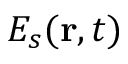<formula> <loc_0><loc_0><loc_500><loc_500>E _ { s } ( r , t )</formula> 